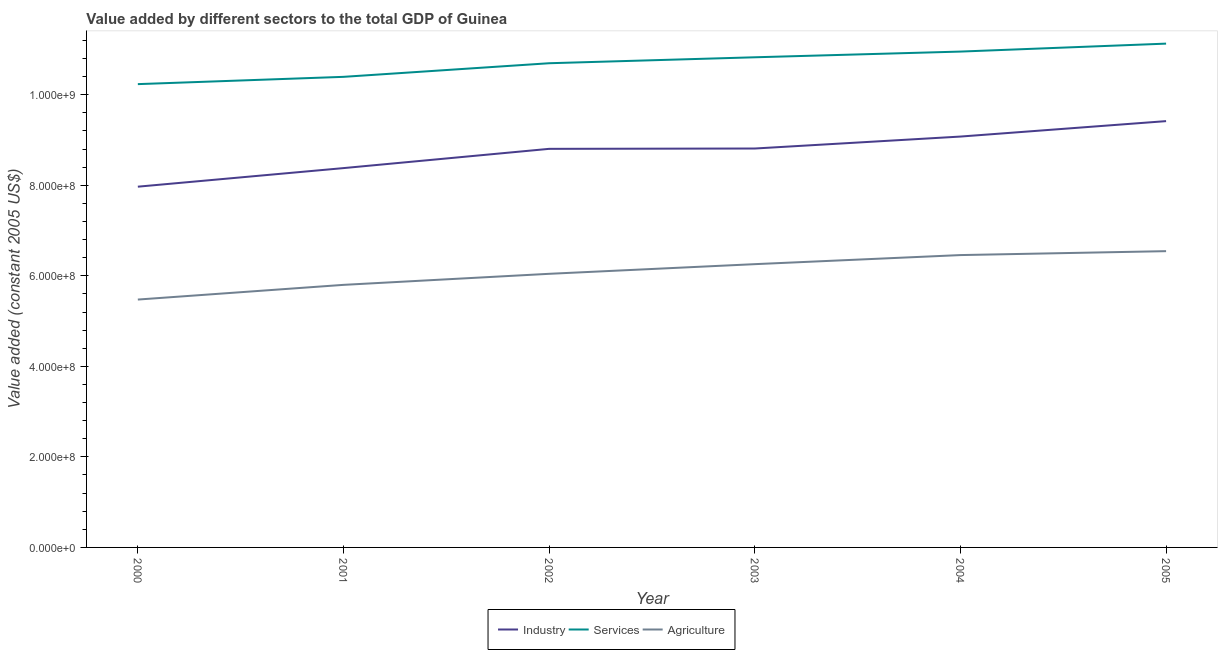How many different coloured lines are there?
Your answer should be compact. 3. What is the value added by services in 2002?
Offer a very short reply. 1.07e+09. Across all years, what is the maximum value added by services?
Your response must be concise. 1.11e+09. Across all years, what is the minimum value added by services?
Offer a terse response. 1.02e+09. In which year was the value added by agricultural sector maximum?
Your response must be concise. 2005. What is the total value added by industrial sector in the graph?
Offer a very short reply. 5.25e+09. What is the difference between the value added by industrial sector in 2004 and that in 2005?
Provide a succinct answer. -3.41e+07. What is the difference between the value added by services in 2004 and the value added by agricultural sector in 2002?
Provide a short and direct response. 4.91e+08. What is the average value added by agricultural sector per year?
Provide a succinct answer. 6.10e+08. In the year 2003, what is the difference between the value added by agricultural sector and value added by industrial sector?
Keep it short and to the point. -2.55e+08. What is the ratio of the value added by industrial sector in 2000 to that in 2005?
Your answer should be very brief. 0.85. Is the difference between the value added by services in 2000 and 2002 greater than the difference between the value added by industrial sector in 2000 and 2002?
Your answer should be very brief. Yes. What is the difference between the highest and the second highest value added by agricultural sector?
Ensure brevity in your answer.  8.65e+06. What is the difference between the highest and the lowest value added by agricultural sector?
Provide a succinct answer. 1.07e+08. Is the sum of the value added by services in 2004 and 2005 greater than the maximum value added by industrial sector across all years?
Provide a succinct answer. Yes. Does the value added by services monotonically increase over the years?
Offer a terse response. Yes. How many years are there in the graph?
Your answer should be very brief. 6. Does the graph contain grids?
Your answer should be very brief. No. Where does the legend appear in the graph?
Your answer should be very brief. Bottom center. How many legend labels are there?
Ensure brevity in your answer.  3. How are the legend labels stacked?
Your answer should be compact. Horizontal. What is the title of the graph?
Give a very brief answer. Value added by different sectors to the total GDP of Guinea. What is the label or title of the Y-axis?
Make the answer very short. Value added (constant 2005 US$). What is the Value added (constant 2005 US$) of Industry in 2000?
Ensure brevity in your answer.  7.97e+08. What is the Value added (constant 2005 US$) in Services in 2000?
Offer a terse response. 1.02e+09. What is the Value added (constant 2005 US$) of Agriculture in 2000?
Your response must be concise. 5.48e+08. What is the Value added (constant 2005 US$) in Industry in 2001?
Provide a succinct answer. 8.38e+08. What is the Value added (constant 2005 US$) in Services in 2001?
Your answer should be very brief. 1.04e+09. What is the Value added (constant 2005 US$) in Agriculture in 2001?
Offer a very short reply. 5.80e+08. What is the Value added (constant 2005 US$) of Industry in 2002?
Offer a very short reply. 8.80e+08. What is the Value added (constant 2005 US$) of Services in 2002?
Offer a terse response. 1.07e+09. What is the Value added (constant 2005 US$) of Agriculture in 2002?
Provide a succinct answer. 6.04e+08. What is the Value added (constant 2005 US$) of Industry in 2003?
Provide a succinct answer. 8.81e+08. What is the Value added (constant 2005 US$) in Services in 2003?
Give a very brief answer. 1.08e+09. What is the Value added (constant 2005 US$) in Agriculture in 2003?
Offer a very short reply. 6.26e+08. What is the Value added (constant 2005 US$) of Industry in 2004?
Your answer should be very brief. 9.08e+08. What is the Value added (constant 2005 US$) of Services in 2004?
Your answer should be very brief. 1.10e+09. What is the Value added (constant 2005 US$) of Agriculture in 2004?
Offer a terse response. 6.46e+08. What is the Value added (constant 2005 US$) in Industry in 2005?
Ensure brevity in your answer.  9.42e+08. What is the Value added (constant 2005 US$) in Services in 2005?
Offer a terse response. 1.11e+09. What is the Value added (constant 2005 US$) in Agriculture in 2005?
Provide a short and direct response. 6.54e+08. Across all years, what is the maximum Value added (constant 2005 US$) in Industry?
Make the answer very short. 9.42e+08. Across all years, what is the maximum Value added (constant 2005 US$) of Services?
Offer a very short reply. 1.11e+09. Across all years, what is the maximum Value added (constant 2005 US$) of Agriculture?
Provide a short and direct response. 6.54e+08. Across all years, what is the minimum Value added (constant 2005 US$) in Industry?
Your response must be concise. 7.97e+08. Across all years, what is the minimum Value added (constant 2005 US$) of Services?
Provide a short and direct response. 1.02e+09. Across all years, what is the minimum Value added (constant 2005 US$) of Agriculture?
Ensure brevity in your answer.  5.48e+08. What is the total Value added (constant 2005 US$) of Industry in the graph?
Keep it short and to the point. 5.25e+09. What is the total Value added (constant 2005 US$) in Services in the graph?
Make the answer very short. 6.42e+09. What is the total Value added (constant 2005 US$) of Agriculture in the graph?
Give a very brief answer. 3.66e+09. What is the difference between the Value added (constant 2005 US$) of Industry in 2000 and that in 2001?
Offer a terse response. -4.10e+07. What is the difference between the Value added (constant 2005 US$) in Services in 2000 and that in 2001?
Offer a very short reply. -1.61e+07. What is the difference between the Value added (constant 2005 US$) in Agriculture in 2000 and that in 2001?
Make the answer very short. -3.24e+07. What is the difference between the Value added (constant 2005 US$) of Industry in 2000 and that in 2002?
Provide a succinct answer. -8.36e+07. What is the difference between the Value added (constant 2005 US$) in Services in 2000 and that in 2002?
Your answer should be very brief. -4.62e+07. What is the difference between the Value added (constant 2005 US$) in Agriculture in 2000 and that in 2002?
Provide a short and direct response. -5.69e+07. What is the difference between the Value added (constant 2005 US$) in Industry in 2000 and that in 2003?
Keep it short and to the point. -8.43e+07. What is the difference between the Value added (constant 2005 US$) of Services in 2000 and that in 2003?
Provide a short and direct response. -5.93e+07. What is the difference between the Value added (constant 2005 US$) in Agriculture in 2000 and that in 2003?
Give a very brief answer. -7.82e+07. What is the difference between the Value added (constant 2005 US$) in Industry in 2000 and that in 2004?
Provide a short and direct response. -1.11e+08. What is the difference between the Value added (constant 2005 US$) of Services in 2000 and that in 2004?
Offer a terse response. -7.19e+07. What is the difference between the Value added (constant 2005 US$) in Agriculture in 2000 and that in 2004?
Offer a very short reply. -9.82e+07. What is the difference between the Value added (constant 2005 US$) in Industry in 2000 and that in 2005?
Offer a terse response. -1.45e+08. What is the difference between the Value added (constant 2005 US$) in Services in 2000 and that in 2005?
Provide a short and direct response. -8.95e+07. What is the difference between the Value added (constant 2005 US$) in Agriculture in 2000 and that in 2005?
Your response must be concise. -1.07e+08. What is the difference between the Value added (constant 2005 US$) of Industry in 2001 and that in 2002?
Your answer should be very brief. -4.25e+07. What is the difference between the Value added (constant 2005 US$) in Services in 2001 and that in 2002?
Ensure brevity in your answer.  -3.01e+07. What is the difference between the Value added (constant 2005 US$) in Agriculture in 2001 and that in 2002?
Make the answer very short. -2.44e+07. What is the difference between the Value added (constant 2005 US$) of Industry in 2001 and that in 2003?
Keep it short and to the point. -4.33e+07. What is the difference between the Value added (constant 2005 US$) of Services in 2001 and that in 2003?
Offer a terse response. -4.32e+07. What is the difference between the Value added (constant 2005 US$) in Agriculture in 2001 and that in 2003?
Your answer should be very brief. -4.57e+07. What is the difference between the Value added (constant 2005 US$) in Industry in 2001 and that in 2004?
Offer a very short reply. -6.97e+07. What is the difference between the Value added (constant 2005 US$) of Services in 2001 and that in 2004?
Provide a short and direct response. -5.58e+07. What is the difference between the Value added (constant 2005 US$) in Agriculture in 2001 and that in 2004?
Your answer should be very brief. -6.58e+07. What is the difference between the Value added (constant 2005 US$) of Industry in 2001 and that in 2005?
Your answer should be very brief. -1.04e+08. What is the difference between the Value added (constant 2005 US$) of Services in 2001 and that in 2005?
Keep it short and to the point. -7.34e+07. What is the difference between the Value added (constant 2005 US$) in Agriculture in 2001 and that in 2005?
Make the answer very short. -7.45e+07. What is the difference between the Value added (constant 2005 US$) of Industry in 2002 and that in 2003?
Offer a terse response. -7.42e+05. What is the difference between the Value added (constant 2005 US$) of Services in 2002 and that in 2003?
Offer a terse response. -1.31e+07. What is the difference between the Value added (constant 2005 US$) of Agriculture in 2002 and that in 2003?
Ensure brevity in your answer.  -2.13e+07. What is the difference between the Value added (constant 2005 US$) in Industry in 2002 and that in 2004?
Your response must be concise. -2.71e+07. What is the difference between the Value added (constant 2005 US$) of Services in 2002 and that in 2004?
Offer a terse response. -2.57e+07. What is the difference between the Value added (constant 2005 US$) in Agriculture in 2002 and that in 2004?
Provide a succinct answer. -4.14e+07. What is the difference between the Value added (constant 2005 US$) in Industry in 2002 and that in 2005?
Your response must be concise. -6.12e+07. What is the difference between the Value added (constant 2005 US$) in Services in 2002 and that in 2005?
Offer a very short reply. -4.33e+07. What is the difference between the Value added (constant 2005 US$) of Agriculture in 2002 and that in 2005?
Provide a succinct answer. -5.00e+07. What is the difference between the Value added (constant 2005 US$) in Industry in 2003 and that in 2004?
Ensure brevity in your answer.  -2.64e+07. What is the difference between the Value added (constant 2005 US$) in Services in 2003 and that in 2004?
Offer a terse response. -1.26e+07. What is the difference between the Value added (constant 2005 US$) in Agriculture in 2003 and that in 2004?
Offer a terse response. -2.01e+07. What is the difference between the Value added (constant 2005 US$) of Industry in 2003 and that in 2005?
Offer a terse response. -6.05e+07. What is the difference between the Value added (constant 2005 US$) of Services in 2003 and that in 2005?
Offer a terse response. -3.02e+07. What is the difference between the Value added (constant 2005 US$) of Agriculture in 2003 and that in 2005?
Your answer should be very brief. -2.87e+07. What is the difference between the Value added (constant 2005 US$) in Industry in 2004 and that in 2005?
Keep it short and to the point. -3.41e+07. What is the difference between the Value added (constant 2005 US$) in Services in 2004 and that in 2005?
Your answer should be very brief. -1.76e+07. What is the difference between the Value added (constant 2005 US$) in Agriculture in 2004 and that in 2005?
Offer a very short reply. -8.65e+06. What is the difference between the Value added (constant 2005 US$) in Industry in 2000 and the Value added (constant 2005 US$) in Services in 2001?
Your response must be concise. -2.43e+08. What is the difference between the Value added (constant 2005 US$) in Industry in 2000 and the Value added (constant 2005 US$) in Agriculture in 2001?
Give a very brief answer. 2.17e+08. What is the difference between the Value added (constant 2005 US$) in Services in 2000 and the Value added (constant 2005 US$) in Agriculture in 2001?
Provide a short and direct response. 4.43e+08. What is the difference between the Value added (constant 2005 US$) in Industry in 2000 and the Value added (constant 2005 US$) in Services in 2002?
Offer a terse response. -2.73e+08. What is the difference between the Value added (constant 2005 US$) in Industry in 2000 and the Value added (constant 2005 US$) in Agriculture in 2002?
Your answer should be very brief. 1.92e+08. What is the difference between the Value added (constant 2005 US$) in Services in 2000 and the Value added (constant 2005 US$) in Agriculture in 2002?
Give a very brief answer. 4.19e+08. What is the difference between the Value added (constant 2005 US$) in Industry in 2000 and the Value added (constant 2005 US$) in Services in 2003?
Offer a terse response. -2.86e+08. What is the difference between the Value added (constant 2005 US$) in Industry in 2000 and the Value added (constant 2005 US$) in Agriculture in 2003?
Provide a short and direct response. 1.71e+08. What is the difference between the Value added (constant 2005 US$) in Services in 2000 and the Value added (constant 2005 US$) in Agriculture in 2003?
Your response must be concise. 3.98e+08. What is the difference between the Value added (constant 2005 US$) of Industry in 2000 and the Value added (constant 2005 US$) of Services in 2004?
Give a very brief answer. -2.98e+08. What is the difference between the Value added (constant 2005 US$) in Industry in 2000 and the Value added (constant 2005 US$) in Agriculture in 2004?
Provide a succinct answer. 1.51e+08. What is the difference between the Value added (constant 2005 US$) in Services in 2000 and the Value added (constant 2005 US$) in Agriculture in 2004?
Provide a succinct answer. 3.78e+08. What is the difference between the Value added (constant 2005 US$) of Industry in 2000 and the Value added (constant 2005 US$) of Services in 2005?
Your response must be concise. -3.16e+08. What is the difference between the Value added (constant 2005 US$) in Industry in 2000 and the Value added (constant 2005 US$) in Agriculture in 2005?
Provide a succinct answer. 1.42e+08. What is the difference between the Value added (constant 2005 US$) in Services in 2000 and the Value added (constant 2005 US$) in Agriculture in 2005?
Your response must be concise. 3.69e+08. What is the difference between the Value added (constant 2005 US$) of Industry in 2001 and the Value added (constant 2005 US$) of Services in 2002?
Your response must be concise. -2.32e+08. What is the difference between the Value added (constant 2005 US$) of Industry in 2001 and the Value added (constant 2005 US$) of Agriculture in 2002?
Keep it short and to the point. 2.33e+08. What is the difference between the Value added (constant 2005 US$) in Services in 2001 and the Value added (constant 2005 US$) in Agriculture in 2002?
Provide a short and direct response. 4.35e+08. What is the difference between the Value added (constant 2005 US$) of Industry in 2001 and the Value added (constant 2005 US$) of Services in 2003?
Make the answer very short. -2.45e+08. What is the difference between the Value added (constant 2005 US$) of Industry in 2001 and the Value added (constant 2005 US$) of Agriculture in 2003?
Provide a succinct answer. 2.12e+08. What is the difference between the Value added (constant 2005 US$) in Services in 2001 and the Value added (constant 2005 US$) in Agriculture in 2003?
Provide a short and direct response. 4.14e+08. What is the difference between the Value added (constant 2005 US$) of Industry in 2001 and the Value added (constant 2005 US$) of Services in 2004?
Give a very brief answer. -2.57e+08. What is the difference between the Value added (constant 2005 US$) in Industry in 2001 and the Value added (constant 2005 US$) in Agriculture in 2004?
Keep it short and to the point. 1.92e+08. What is the difference between the Value added (constant 2005 US$) in Services in 2001 and the Value added (constant 2005 US$) in Agriculture in 2004?
Provide a succinct answer. 3.94e+08. What is the difference between the Value added (constant 2005 US$) in Industry in 2001 and the Value added (constant 2005 US$) in Services in 2005?
Offer a terse response. -2.75e+08. What is the difference between the Value added (constant 2005 US$) of Industry in 2001 and the Value added (constant 2005 US$) of Agriculture in 2005?
Offer a very short reply. 1.83e+08. What is the difference between the Value added (constant 2005 US$) in Services in 2001 and the Value added (constant 2005 US$) in Agriculture in 2005?
Provide a short and direct response. 3.85e+08. What is the difference between the Value added (constant 2005 US$) in Industry in 2002 and the Value added (constant 2005 US$) in Services in 2003?
Your answer should be very brief. -2.02e+08. What is the difference between the Value added (constant 2005 US$) in Industry in 2002 and the Value added (constant 2005 US$) in Agriculture in 2003?
Your response must be concise. 2.55e+08. What is the difference between the Value added (constant 2005 US$) of Services in 2002 and the Value added (constant 2005 US$) of Agriculture in 2003?
Ensure brevity in your answer.  4.44e+08. What is the difference between the Value added (constant 2005 US$) of Industry in 2002 and the Value added (constant 2005 US$) of Services in 2004?
Your answer should be very brief. -2.15e+08. What is the difference between the Value added (constant 2005 US$) in Industry in 2002 and the Value added (constant 2005 US$) in Agriculture in 2004?
Your answer should be compact. 2.35e+08. What is the difference between the Value added (constant 2005 US$) in Services in 2002 and the Value added (constant 2005 US$) in Agriculture in 2004?
Make the answer very short. 4.24e+08. What is the difference between the Value added (constant 2005 US$) of Industry in 2002 and the Value added (constant 2005 US$) of Services in 2005?
Your response must be concise. -2.32e+08. What is the difference between the Value added (constant 2005 US$) in Industry in 2002 and the Value added (constant 2005 US$) in Agriculture in 2005?
Provide a short and direct response. 2.26e+08. What is the difference between the Value added (constant 2005 US$) in Services in 2002 and the Value added (constant 2005 US$) in Agriculture in 2005?
Your answer should be compact. 4.15e+08. What is the difference between the Value added (constant 2005 US$) of Industry in 2003 and the Value added (constant 2005 US$) of Services in 2004?
Your answer should be very brief. -2.14e+08. What is the difference between the Value added (constant 2005 US$) in Industry in 2003 and the Value added (constant 2005 US$) in Agriculture in 2004?
Keep it short and to the point. 2.35e+08. What is the difference between the Value added (constant 2005 US$) of Services in 2003 and the Value added (constant 2005 US$) of Agriculture in 2004?
Your answer should be very brief. 4.37e+08. What is the difference between the Value added (constant 2005 US$) of Industry in 2003 and the Value added (constant 2005 US$) of Services in 2005?
Your answer should be compact. -2.32e+08. What is the difference between the Value added (constant 2005 US$) in Industry in 2003 and the Value added (constant 2005 US$) in Agriculture in 2005?
Ensure brevity in your answer.  2.27e+08. What is the difference between the Value added (constant 2005 US$) of Services in 2003 and the Value added (constant 2005 US$) of Agriculture in 2005?
Give a very brief answer. 4.28e+08. What is the difference between the Value added (constant 2005 US$) in Industry in 2004 and the Value added (constant 2005 US$) in Services in 2005?
Your response must be concise. -2.05e+08. What is the difference between the Value added (constant 2005 US$) in Industry in 2004 and the Value added (constant 2005 US$) in Agriculture in 2005?
Your answer should be very brief. 2.53e+08. What is the difference between the Value added (constant 2005 US$) in Services in 2004 and the Value added (constant 2005 US$) in Agriculture in 2005?
Make the answer very short. 4.41e+08. What is the average Value added (constant 2005 US$) in Industry per year?
Offer a very short reply. 8.74e+08. What is the average Value added (constant 2005 US$) in Services per year?
Offer a terse response. 1.07e+09. What is the average Value added (constant 2005 US$) of Agriculture per year?
Your response must be concise. 6.10e+08. In the year 2000, what is the difference between the Value added (constant 2005 US$) in Industry and Value added (constant 2005 US$) in Services?
Your answer should be compact. -2.27e+08. In the year 2000, what is the difference between the Value added (constant 2005 US$) in Industry and Value added (constant 2005 US$) in Agriculture?
Your answer should be very brief. 2.49e+08. In the year 2000, what is the difference between the Value added (constant 2005 US$) of Services and Value added (constant 2005 US$) of Agriculture?
Ensure brevity in your answer.  4.76e+08. In the year 2001, what is the difference between the Value added (constant 2005 US$) of Industry and Value added (constant 2005 US$) of Services?
Ensure brevity in your answer.  -2.02e+08. In the year 2001, what is the difference between the Value added (constant 2005 US$) in Industry and Value added (constant 2005 US$) in Agriculture?
Give a very brief answer. 2.58e+08. In the year 2001, what is the difference between the Value added (constant 2005 US$) in Services and Value added (constant 2005 US$) in Agriculture?
Provide a short and direct response. 4.59e+08. In the year 2002, what is the difference between the Value added (constant 2005 US$) of Industry and Value added (constant 2005 US$) of Services?
Offer a terse response. -1.89e+08. In the year 2002, what is the difference between the Value added (constant 2005 US$) in Industry and Value added (constant 2005 US$) in Agriculture?
Offer a terse response. 2.76e+08. In the year 2002, what is the difference between the Value added (constant 2005 US$) in Services and Value added (constant 2005 US$) in Agriculture?
Offer a terse response. 4.65e+08. In the year 2003, what is the difference between the Value added (constant 2005 US$) of Industry and Value added (constant 2005 US$) of Services?
Your answer should be very brief. -2.01e+08. In the year 2003, what is the difference between the Value added (constant 2005 US$) of Industry and Value added (constant 2005 US$) of Agriculture?
Give a very brief answer. 2.55e+08. In the year 2003, what is the difference between the Value added (constant 2005 US$) of Services and Value added (constant 2005 US$) of Agriculture?
Make the answer very short. 4.57e+08. In the year 2004, what is the difference between the Value added (constant 2005 US$) in Industry and Value added (constant 2005 US$) in Services?
Offer a terse response. -1.88e+08. In the year 2004, what is the difference between the Value added (constant 2005 US$) of Industry and Value added (constant 2005 US$) of Agriculture?
Offer a very short reply. 2.62e+08. In the year 2004, what is the difference between the Value added (constant 2005 US$) of Services and Value added (constant 2005 US$) of Agriculture?
Offer a very short reply. 4.49e+08. In the year 2005, what is the difference between the Value added (constant 2005 US$) in Industry and Value added (constant 2005 US$) in Services?
Offer a very short reply. -1.71e+08. In the year 2005, what is the difference between the Value added (constant 2005 US$) of Industry and Value added (constant 2005 US$) of Agriculture?
Make the answer very short. 2.87e+08. In the year 2005, what is the difference between the Value added (constant 2005 US$) in Services and Value added (constant 2005 US$) in Agriculture?
Provide a succinct answer. 4.58e+08. What is the ratio of the Value added (constant 2005 US$) of Industry in 2000 to that in 2001?
Offer a very short reply. 0.95. What is the ratio of the Value added (constant 2005 US$) in Services in 2000 to that in 2001?
Your answer should be compact. 0.98. What is the ratio of the Value added (constant 2005 US$) in Agriculture in 2000 to that in 2001?
Keep it short and to the point. 0.94. What is the ratio of the Value added (constant 2005 US$) in Industry in 2000 to that in 2002?
Provide a short and direct response. 0.91. What is the ratio of the Value added (constant 2005 US$) of Services in 2000 to that in 2002?
Provide a short and direct response. 0.96. What is the ratio of the Value added (constant 2005 US$) in Agriculture in 2000 to that in 2002?
Your answer should be very brief. 0.91. What is the ratio of the Value added (constant 2005 US$) of Industry in 2000 to that in 2003?
Provide a short and direct response. 0.9. What is the ratio of the Value added (constant 2005 US$) in Services in 2000 to that in 2003?
Your answer should be compact. 0.95. What is the ratio of the Value added (constant 2005 US$) of Industry in 2000 to that in 2004?
Give a very brief answer. 0.88. What is the ratio of the Value added (constant 2005 US$) in Services in 2000 to that in 2004?
Make the answer very short. 0.93. What is the ratio of the Value added (constant 2005 US$) in Agriculture in 2000 to that in 2004?
Keep it short and to the point. 0.85. What is the ratio of the Value added (constant 2005 US$) of Industry in 2000 to that in 2005?
Offer a terse response. 0.85. What is the ratio of the Value added (constant 2005 US$) of Services in 2000 to that in 2005?
Provide a succinct answer. 0.92. What is the ratio of the Value added (constant 2005 US$) of Agriculture in 2000 to that in 2005?
Make the answer very short. 0.84. What is the ratio of the Value added (constant 2005 US$) in Industry in 2001 to that in 2002?
Your answer should be compact. 0.95. What is the ratio of the Value added (constant 2005 US$) of Services in 2001 to that in 2002?
Offer a very short reply. 0.97. What is the ratio of the Value added (constant 2005 US$) of Agriculture in 2001 to that in 2002?
Give a very brief answer. 0.96. What is the ratio of the Value added (constant 2005 US$) in Industry in 2001 to that in 2003?
Ensure brevity in your answer.  0.95. What is the ratio of the Value added (constant 2005 US$) of Services in 2001 to that in 2003?
Offer a very short reply. 0.96. What is the ratio of the Value added (constant 2005 US$) of Agriculture in 2001 to that in 2003?
Your answer should be very brief. 0.93. What is the ratio of the Value added (constant 2005 US$) of Industry in 2001 to that in 2004?
Keep it short and to the point. 0.92. What is the ratio of the Value added (constant 2005 US$) in Services in 2001 to that in 2004?
Provide a short and direct response. 0.95. What is the ratio of the Value added (constant 2005 US$) in Agriculture in 2001 to that in 2004?
Ensure brevity in your answer.  0.9. What is the ratio of the Value added (constant 2005 US$) of Industry in 2001 to that in 2005?
Offer a very short reply. 0.89. What is the ratio of the Value added (constant 2005 US$) in Services in 2001 to that in 2005?
Offer a very short reply. 0.93. What is the ratio of the Value added (constant 2005 US$) in Agriculture in 2001 to that in 2005?
Ensure brevity in your answer.  0.89. What is the ratio of the Value added (constant 2005 US$) in Industry in 2002 to that in 2003?
Provide a succinct answer. 1. What is the ratio of the Value added (constant 2005 US$) of Services in 2002 to that in 2003?
Provide a succinct answer. 0.99. What is the ratio of the Value added (constant 2005 US$) of Agriculture in 2002 to that in 2003?
Give a very brief answer. 0.97. What is the ratio of the Value added (constant 2005 US$) of Industry in 2002 to that in 2004?
Make the answer very short. 0.97. What is the ratio of the Value added (constant 2005 US$) in Services in 2002 to that in 2004?
Make the answer very short. 0.98. What is the ratio of the Value added (constant 2005 US$) in Agriculture in 2002 to that in 2004?
Keep it short and to the point. 0.94. What is the ratio of the Value added (constant 2005 US$) in Industry in 2002 to that in 2005?
Provide a short and direct response. 0.94. What is the ratio of the Value added (constant 2005 US$) in Services in 2002 to that in 2005?
Your answer should be very brief. 0.96. What is the ratio of the Value added (constant 2005 US$) in Agriculture in 2002 to that in 2005?
Your answer should be compact. 0.92. What is the ratio of the Value added (constant 2005 US$) of Industry in 2003 to that in 2004?
Provide a succinct answer. 0.97. What is the ratio of the Value added (constant 2005 US$) in Agriculture in 2003 to that in 2004?
Your answer should be very brief. 0.97. What is the ratio of the Value added (constant 2005 US$) in Industry in 2003 to that in 2005?
Offer a terse response. 0.94. What is the ratio of the Value added (constant 2005 US$) in Services in 2003 to that in 2005?
Your answer should be very brief. 0.97. What is the ratio of the Value added (constant 2005 US$) of Agriculture in 2003 to that in 2005?
Offer a terse response. 0.96. What is the ratio of the Value added (constant 2005 US$) in Industry in 2004 to that in 2005?
Make the answer very short. 0.96. What is the ratio of the Value added (constant 2005 US$) of Services in 2004 to that in 2005?
Your answer should be very brief. 0.98. What is the difference between the highest and the second highest Value added (constant 2005 US$) of Industry?
Give a very brief answer. 3.41e+07. What is the difference between the highest and the second highest Value added (constant 2005 US$) in Services?
Provide a short and direct response. 1.76e+07. What is the difference between the highest and the second highest Value added (constant 2005 US$) in Agriculture?
Keep it short and to the point. 8.65e+06. What is the difference between the highest and the lowest Value added (constant 2005 US$) in Industry?
Your answer should be compact. 1.45e+08. What is the difference between the highest and the lowest Value added (constant 2005 US$) in Services?
Offer a very short reply. 8.95e+07. What is the difference between the highest and the lowest Value added (constant 2005 US$) of Agriculture?
Offer a terse response. 1.07e+08. 